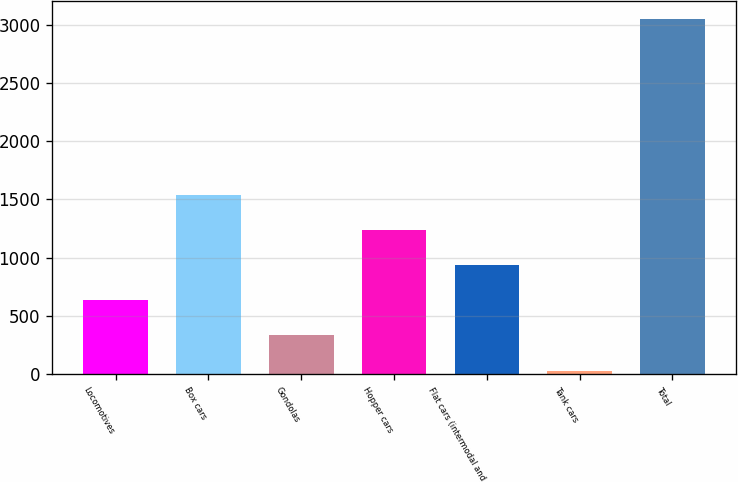Convert chart to OTSL. <chart><loc_0><loc_0><loc_500><loc_500><bar_chart><fcel>Locomotives<fcel>Box cars<fcel>Gondolas<fcel>Hopper cars<fcel>Flat cars (intermodal and<fcel>Tank cars<fcel>Total<nl><fcel>633.6<fcel>1542<fcel>330.8<fcel>1239.2<fcel>936.4<fcel>28<fcel>3056<nl></chart> 